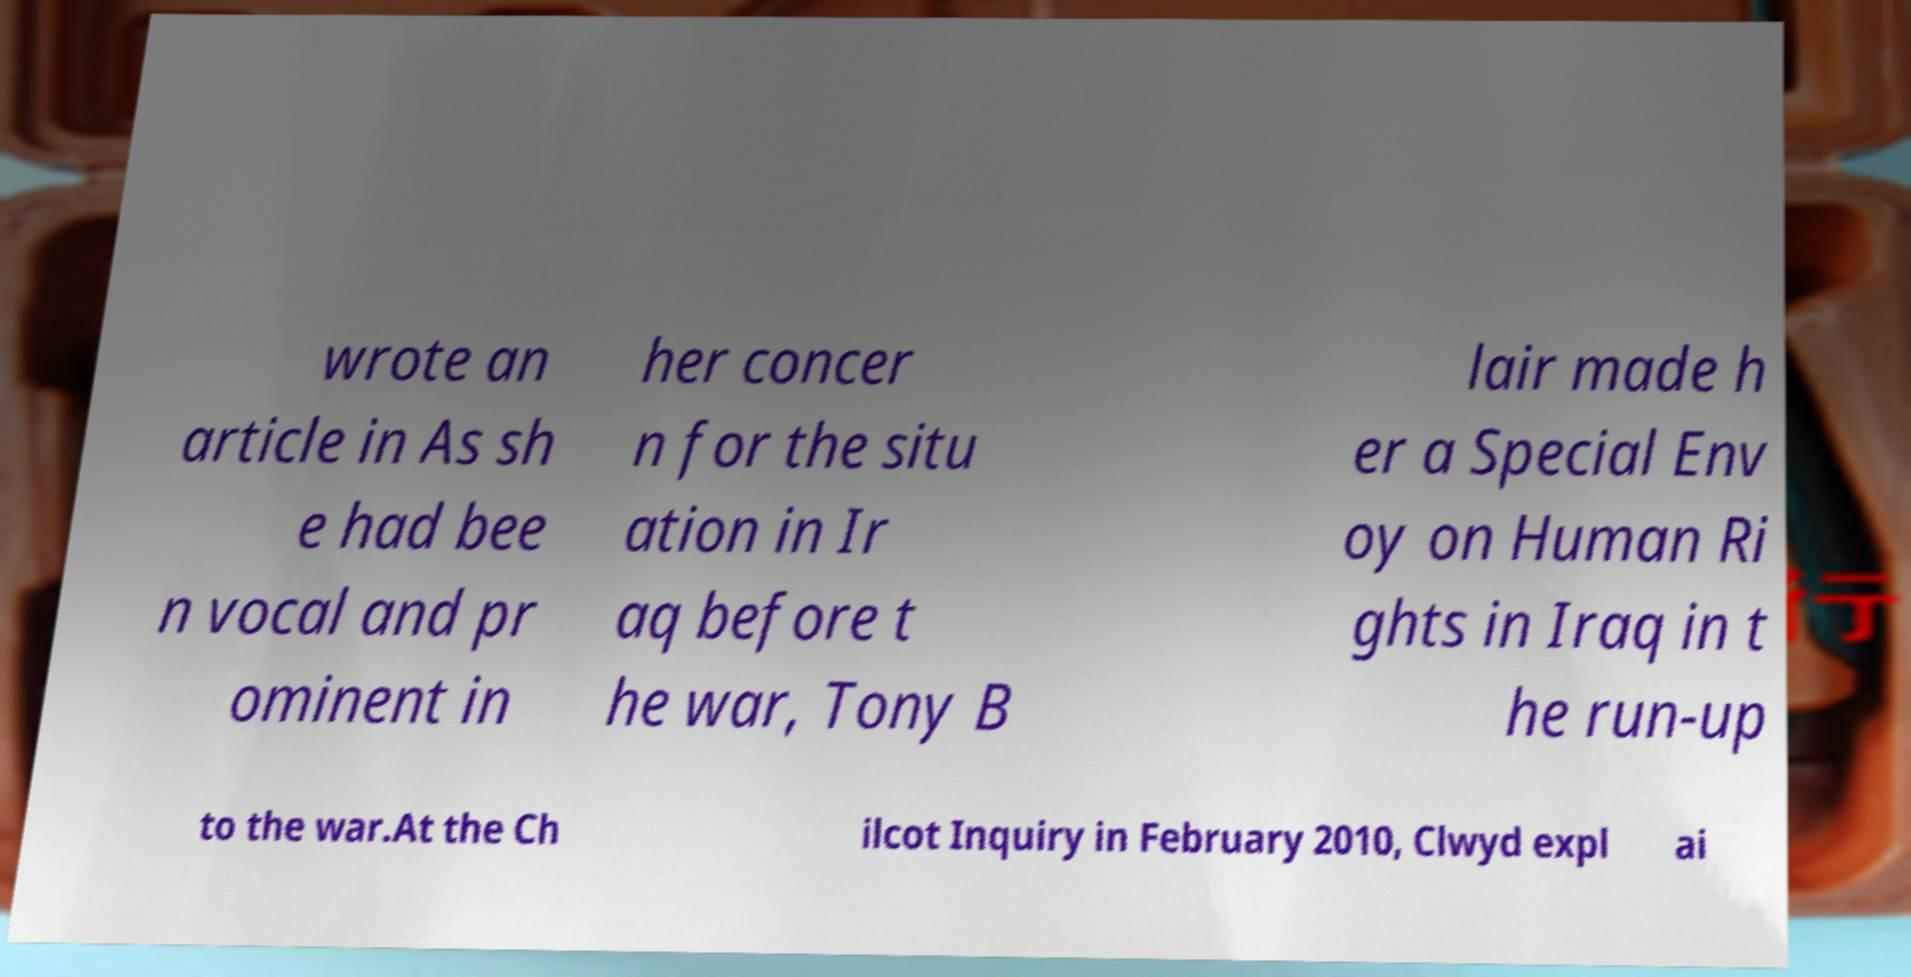Could you extract and type out the text from this image? wrote an article in As sh e had bee n vocal and pr ominent in her concer n for the situ ation in Ir aq before t he war, Tony B lair made h er a Special Env oy on Human Ri ghts in Iraq in t he run-up to the war.At the Ch ilcot Inquiry in February 2010, Clwyd expl ai 